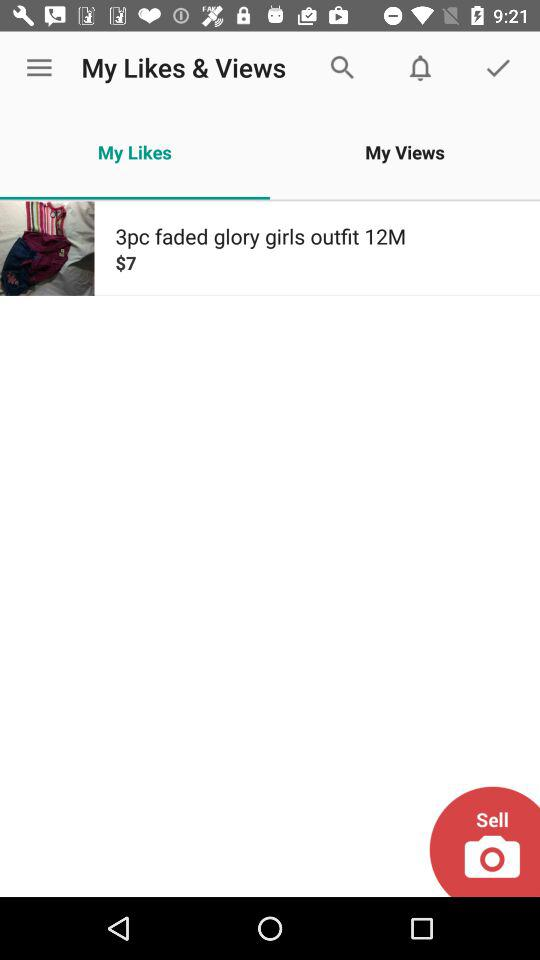What's the price of the outfit? The price of the outfit is $7. 